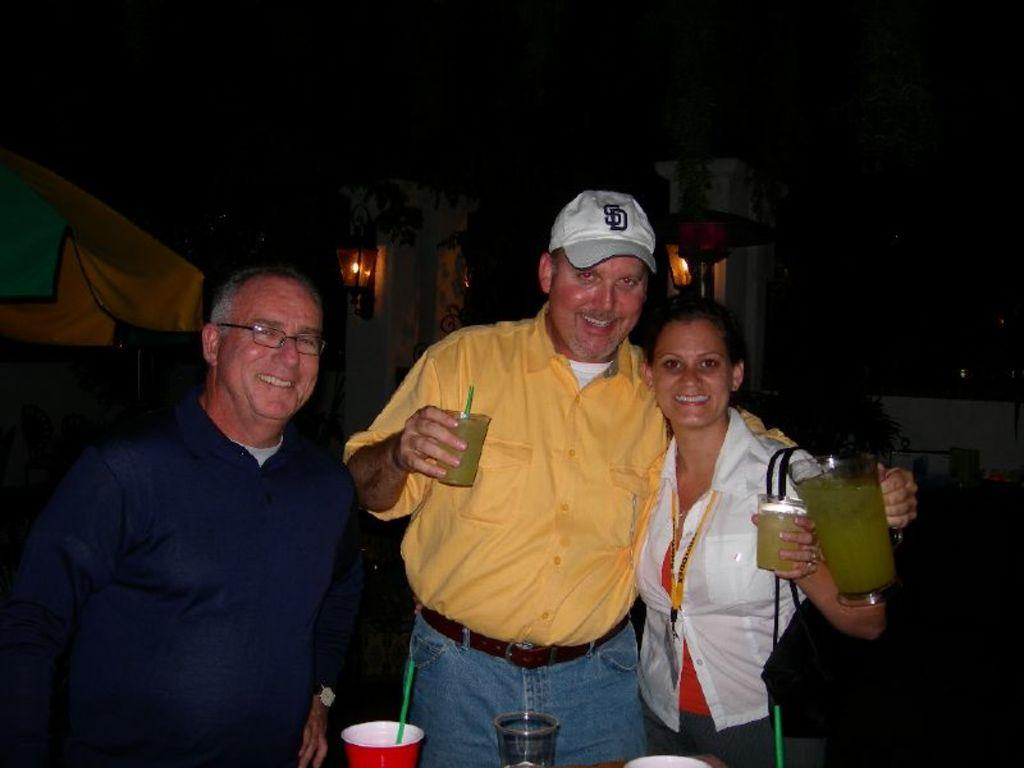Provide a one-sentence caption for the provided image. A man in a yellow shirt is wearing a white SD baseball cap. 